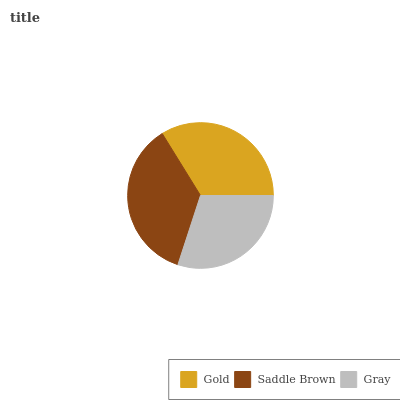Is Gray the minimum?
Answer yes or no. Yes. Is Saddle Brown the maximum?
Answer yes or no. Yes. Is Saddle Brown the minimum?
Answer yes or no. No. Is Gray the maximum?
Answer yes or no. No. Is Saddle Brown greater than Gray?
Answer yes or no. Yes. Is Gray less than Saddle Brown?
Answer yes or no. Yes. Is Gray greater than Saddle Brown?
Answer yes or no. No. Is Saddle Brown less than Gray?
Answer yes or no. No. Is Gold the high median?
Answer yes or no. Yes. Is Gold the low median?
Answer yes or no. Yes. Is Gray the high median?
Answer yes or no. No. Is Gray the low median?
Answer yes or no. No. 